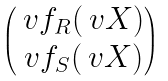<formula> <loc_0><loc_0><loc_500><loc_500>\begin{pmatrix} \ v f _ { R } ( \ v X ) \\ \ v f _ { S } ( \ v X ) \end{pmatrix}</formula> 